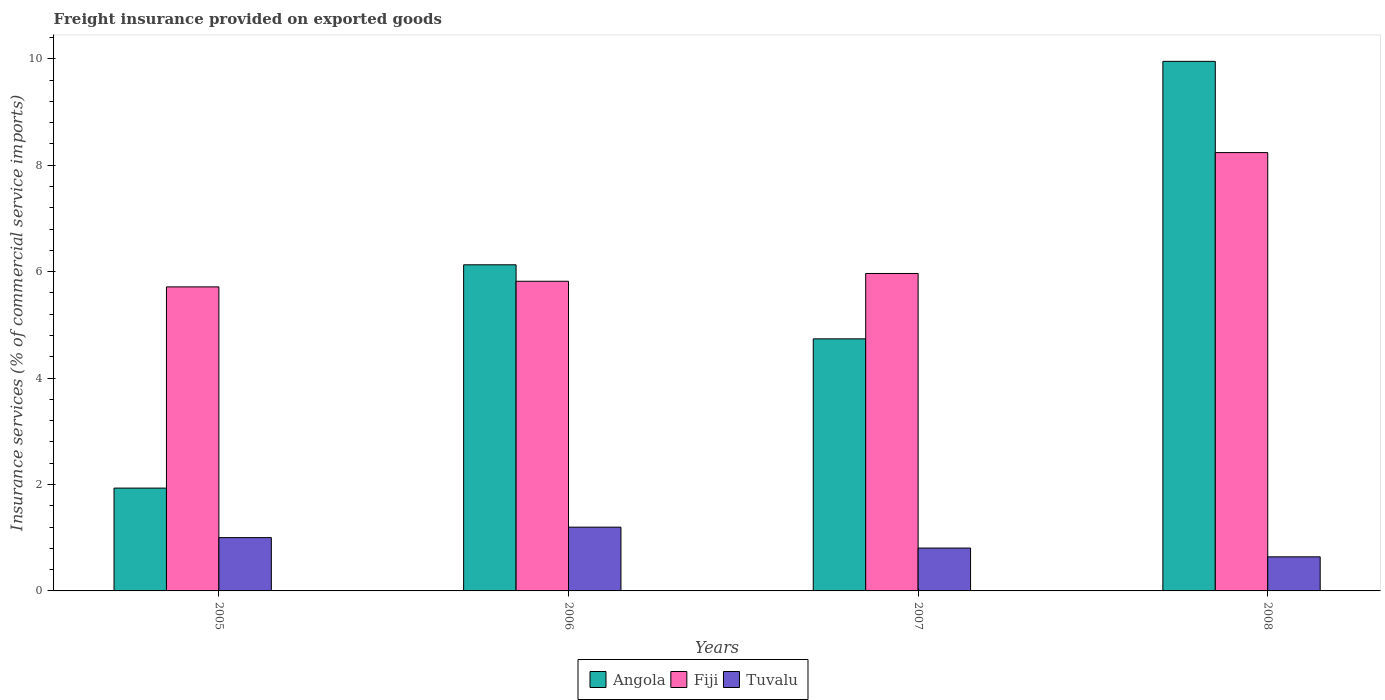How many different coloured bars are there?
Offer a terse response. 3. Are the number of bars per tick equal to the number of legend labels?
Give a very brief answer. Yes. How many bars are there on the 4th tick from the left?
Your answer should be very brief. 3. What is the label of the 3rd group of bars from the left?
Keep it short and to the point. 2007. What is the freight insurance provided on exported goods in Angola in 2005?
Your response must be concise. 1.93. Across all years, what is the maximum freight insurance provided on exported goods in Angola?
Your response must be concise. 9.95. Across all years, what is the minimum freight insurance provided on exported goods in Fiji?
Ensure brevity in your answer.  5.71. In which year was the freight insurance provided on exported goods in Tuvalu minimum?
Offer a very short reply. 2008. What is the total freight insurance provided on exported goods in Fiji in the graph?
Offer a terse response. 25.73. What is the difference between the freight insurance provided on exported goods in Fiji in 2006 and that in 2007?
Give a very brief answer. -0.15. What is the difference between the freight insurance provided on exported goods in Angola in 2007 and the freight insurance provided on exported goods in Tuvalu in 2008?
Ensure brevity in your answer.  4.1. What is the average freight insurance provided on exported goods in Fiji per year?
Provide a succinct answer. 6.43. In the year 2007, what is the difference between the freight insurance provided on exported goods in Angola and freight insurance provided on exported goods in Tuvalu?
Ensure brevity in your answer.  3.93. What is the ratio of the freight insurance provided on exported goods in Angola in 2005 to that in 2007?
Provide a succinct answer. 0.41. Is the freight insurance provided on exported goods in Angola in 2006 less than that in 2008?
Provide a succinct answer. Yes. What is the difference between the highest and the second highest freight insurance provided on exported goods in Angola?
Give a very brief answer. 3.82. What is the difference between the highest and the lowest freight insurance provided on exported goods in Fiji?
Your answer should be very brief. 2.52. In how many years, is the freight insurance provided on exported goods in Fiji greater than the average freight insurance provided on exported goods in Fiji taken over all years?
Your answer should be very brief. 1. What does the 1st bar from the left in 2005 represents?
Offer a very short reply. Angola. What does the 1st bar from the right in 2007 represents?
Offer a very short reply. Tuvalu. Is it the case that in every year, the sum of the freight insurance provided on exported goods in Fiji and freight insurance provided on exported goods in Angola is greater than the freight insurance provided on exported goods in Tuvalu?
Your answer should be compact. Yes. Are the values on the major ticks of Y-axis written in scientific E-notation?
Your response must be concise. No. Does the graph contain any zero values?
Provide a short and direct response. No. Does the graph contain grids?
Provide a succinct answer. No. Where does the legend appear in the graph?
Offer a very short reply. Bottom center. How many legend labels are there?
Provide a succinct answer. 3. What is the title of the graph?
Offer a very short reply. Freight insurance provided on exported goods. What is the label or title of the X-axis?
Make the answer very short. Years. What is the label or title of the Y-axis?
Ensure brevity in your answer.  Insurance services (% of commercial service imports). What is the Insurance services (% of commercial service imports) in Angola in 2005?
Offer a terse response. 1.93. What is the Insurance services (% of commercial service imports) in Fiji in 2005?
Your response must be concise. 5.71. What is the Insurance services (% of commercial service imports) in Tuvalu in 2005?
Your answer should be very brief. 1. What is the Insurance services (% of commercial service imports) in Angola in 2006?
Your answer should be very brief. 6.13. What is the Insurance services (% of commercial service imports) of Fiji in 2006?
Give a very brief answer. 5.82. What is the Insurance services (% of commercial service imports) in Tuvalu in 2006?
Ensure brevity in your answer.  1.2. What is the Insurance services (% of commercial service imports) in Angola in 2007?
Make the answer very short. 4.74. What is the Insurance services (% of commercial service imports) in Fiji in 2007?
Ensure brevity in your answer.  5.97. What is the Insurance services (% of commercial service imports) of Tuvalu in 2007?
Your response must be concise. 0.81. What is the Insurance services (% of commercial service imports) in Angola in 2008?
Make the answer very short. 9.95. What is the Insurance services (% of commercial service imports) in Fiji in 2008?
Your answer should be very brief. 8.24. What is the Insurance services (% of commercial service imports) in Tuvalu in 2008?
Give a very brief answer. 0.64. Across all years, what is the maximum Insurance services (% of commercial service imports) in Angola?
Your answer should be compact. 9.95. Across all years, what is the maximum Insurance services (% of commercial service imports) in Fiji?
Ensure brevity in your answer.  8.24. Across all years, what is the maximum Insurance services (% of commercial service imports) of Tuvalu?
Provide a short and direct response. 1.2. Across all years, what is the minimum Insurance services (% of commercial service imports) of Angola?
Keep it short and to the point. 1.93. Across all years, what is the minimum Insurance services (% of commercial service imports) in Fiji?
Offer a terse response. 5.71. Across all years, what is the minimum Insurance services (% of commercial service imports) in Tuvalu?
Make the answer very short. 0.64. What is the total Insurance services (% of commercial service imports) in Angola in the graph?
Offer a very short reply. 22.75. What is the total Insurance services (% of commercial service imports) in Fiji in the graph?
Provide a succinct answer. 25.73. What is the total Insurance services (% of commercial service imports) in Tuvalu in the graph?
Your response must be concise. 3.65. What is the difference between the Insurance services (% of commercial service imports) in Angola in 2005 and that in 2006?
Provide a short and direct response. -4.2. What is the difference between the Insurance services (% of commercial service imports) of Fiji in 2005 and that in 2006?
Offer a terse response. -0.11. What is the difference between the Insurance services (% of commercial service imports) of Tuvalu in 2005 and that in 2006?
Offer a terse response. -0.2. What is the difference between the Insurance services (% of commercial service imports) of Angola in 2005 and that in 2007?
Provide a succinct answer. -2.8. What is the difference between the Insurance services (% of commercial service imports) of Fiji in 2005 and that in 2007?
Provide a short and direct response. -0.25. What is the difference between the Insurance services (% of commercial service imports) of Tuvalu in 2005 and that in 2007?
Your answer should be compact. 0.2. What is the difference between the Insurance services (% of commercial service imports) in Angola in 2005 and that in 2008?
Offer a very short reply. -8.02. What is the difference between the Insurance services (% of commercial service imports) of Fiji in 2005 and that in 2008?
Keep it short and to the point. -2.52. What is the difference between the Insurance services (% of commercial service imports) of Tuvalu in 2005 and that in 2008?
Provide a short and direct response. 0.36. What is the difference between the Insurance services (% of commercial service imports) of Angola in 2006 and that in 2007?
Provide a succinct answer. 1.39. What is the difference between the Insurance services (% of commercial service imports) of Fiji in 2006 and that in 2007?
Offer a terse response. -0.15. What is the difference between the Insurance services (% of commercial service imports) of Tuvalu in 2006 and that in 2007?
Ensure brevity in your answer.  0.39. What is the difference between the Insurance services (% of commercial service imports) of Angola in 2006 and that in 2008?
Provide a short and direct response. -3.82. What is the difference between the Insurance services (% of commercial service imports) of Fiji in 2006 and that in 2008?
Your response must be concise. -2.42. What is the difference between the Insurance services (% of commercial service imports) of Tuvalu in 2006 and that in 2008?
Provide a succinct answer. 0.56. What is the difference between the Insurance services (% of commercial service imports) in Angola in 2007 and that in 2008?
Provide a short and direct response. -5.21. What is the difference between the Insurance services (% of commercial service imports) of Fiji in 2007 and that in 2008?
Ensure brevity in your answer.  -2.27. What is the difference between the Insurance services (% of commercial service imports) of Tuvalu in 2007 and that in 2008?
Offer a very short reply. 0.16. What is the difference between the Insurance services (% of commercial service imports) of Angola in 2005 and the Insurance services (% of commercial service imports) of Fiji in 2006?
Provide a succinct answer. -3.89. What is the difference between the Insurance services (% of commercial service imports) in Angola in 2005 and the Insurance services (% of commercial service imports) in Tuvalu in 2006?
Provide a succinct answer. 0.73. What is the difference between the Insurance services (% of commercial service imports) in Fiji in 2005 and the Insurance services (% of commercial service imports) in Tuvalu in 2006?
Make the answer very short. 4.52. What is the difference between the Insurance services (% of commercial service imports) of Angola in 2005 and the Insurance services (% of commercial service imports) of Fiji in 2007?
Ensure brevity in your answer.  -4.03. What is the difference between the Insurance services (% of commercial service imports) of Angola in 2005 and the Insurance services (% of commercial service imports) of Tuvalu in 2007?
Offer a very short reply. 1.13. What is the difference between the Insurance services (% of commercial service imports) in Fiji in 2005 and the Insurance services (% of commercial service imports) in Tuvalu in 2007?
Ensure brevity in your answer.  4.91. What is the difference between the Insurance services (% of commercial service imports) of Angola in 2005 and the Insurance services (% of commercial service imports) of Fiji in 2008?
Your response must be concise. -6.3. What is the difference between the Insurance services (% of commercial service imports) of Angola in 2005 and the Insurance services (% of commercial service imports) of Tuvalu in 2008?
Keep it short and to the point. 1.29. What is the difference between the Insurance services (% of commercial service imports) of Fiji in 2005 and the Insurance services (% of commercial service imports) of Tuvalu in 2008?
Offer a very short reply. 5.07. What is the difference between the Insurance services (% of commercial service imports) of Angola in 2006 and the Insurance services (% of commercial service imports) of Fiji in 2007?
Provide a succinct answer. 0.16. What is the difference between the Insurance services (% of commercial service imports) of Angola in 2006 and the Insurance services (% of commercial service imports) of Tuvalu in 2007?
Your answer should be very brief. 5.32. What is the difference between the Insurance services (% of commercial service imports) of Fiji in 2006 and the Insurance services (% of commercial service imports) of Tuvalu in 2007?
Your answer should be very brief. 5.01. What is the difference between the Insurance services (% of commercial service imports) in Angola in 2006 and the Insurance services (% of commercial service imports) in Fiji in 2008?
Offer a very short reply. -2.11. What is the difference between the Insurance services (% of commercial service imports) of Angola in 2006 and the Insurance services (% of commercial service imports) of Tuvalu in 2008?
Offer a terse response. 5.49. What is the difference between the Insurance services (% of commercial service imports) in Fiji in 2006 and the Insurance services (% of commercial service imports) in Tuvalu in 2008?
Provide a succinct answer. 5.18. What is the difference between the Insurance services (% of commercial service imports) in Angola in 2007 and the Insurance services (% of commercial service imports) in Fiji in 2008?
Your answer should be very brief. -3.5. What is the difference between the Insurance services (% of commercial service imports) of Angola in 2007 and the Insurance services (% of commercial service imports) of Tuvalu in 2008?
Provide a succinct answer. 4.1. What is the difference between the Insurance services (% of commercial service imports) in Fiji in 2007 and the Insurance services (% of commercial service imports) in Tuvalu in 2008?
Ensure brevity in your answer.  5.32. What is the average Insurance services (% of commercial service imports) in Angola per year?
Your answer should be compact. 5.69. What is the average Insurance services (% of commercial service imports) in Fiji per year?
Ensure brevity in your answer.  6.43. What is the average Insurance services (% of commercial service imports) of Tuvalu per year?
Offer a very short reply. 0.91. In the year 2005, what is the difference between the Insurance services (% of commercial service imports) of Angola and Insurance services (% of commercial service imports) of Fiji?
Provide a succinct answer. -3.78. In the year 2005, what is the difference between the Insurance services (% of commercial service imports) in Angola and Insurance services (% of commercial service imports) in Tuvalu?
Keep it short and to the point. 0.93. In the year 2005, what is the difference between the Insurance services (% of commercial service imports) of Fiji and Insurance services (% of commercial service imports) of Tuvalu?
Offer a very short reply. 4.71. In the year 2006, what is the difference between the Insurance services (% of commercial service imports) in Angola and Insurance services (% of commercial service imports) in Fiji?
Your response must be concise. 0.31. In the year 2006, what is the difference between the Insurance services (% of commercial service imports) in Angola and Insurance services (% of commercial service imports) in Tuvalu?
Offer a terse response. 4.93. In the year 2006, what is the difference between the Insurance services (% of commercial service imports) of Fiji and Insurance services (% of commercial service imports) of Tuvalu?
Make the answer very short. 4.62. In the year 2007, what is the difference between the Insurance services (% of commercial service imports) of Angola and Insurance services (% of commercial service imports) of Fiji?
Your response must be concise. -1.23. In the year 2007, what is the difference between the Insurance services (% of commercial service imports) in Angola and Insurance services (% of commercial service imports) in Tuvalu?
Your answer should be very brief. 3.93. In the year 2007, what is the difference between the Insurance services (% of commercial service imports) of Fiji and Insurance services (% of commercial service imports) of Tuvalu?
Keep it short and to the point. 5.16. In the year 2008, what is the difference between the Insurance services (% of commercial service imports) of Angola and Insurance services (% of commercial service imports) of Fiji?
Offer a very short reply. 1.71. In the year 2008, what is the difference between the Insurance services (% of commercial service imports) of Angola and Insurance services (% of commercial service imports) of Tuvalu?
Your response must be concise. 9.31. In the year 2008, what is the difference between the Insurance services (% of commercial service imports) in Fiji and Insurance services (% of commercial service imports) in Tuvalu?
Provide a short and direct response. 7.6. What is the ratio of the Insurance services (% of commercial service imports) in Angola in 2005 to that in 2006?
Your answer should be very brief. 0.32. What is the ratio of the Insurance services (% of commercial service imports) in Fiji in 2005 to that in 2006?
Make the answer very short. 0.98. What is the ratio of the Insurance services (% of commercial service imports) of Tuvalu in 2005 to that in 2006?
Your answer should be very brief. 0.84. What is the ratio of the Insurance services (% of commercial service imports) of Angola in 2005 to that in 2007?
Provide a short and direct response. 0.41. What is the ratio of the Insurance services (% of commercial service imports) of Fiji in 2005 to that in 2007?
Offer a very short reply. 0.96. What is the ratio of the Insurance services (% of commercial service imports) in Tuvalu in 2005 to that in 2007?
Ensure brevity in your answer.  1.24. What is the ratio of the Insurance services (% of commercial service imports) in Angola in 2005 to that in 2008?
Your answer should be very brief. 0.19. What is the ratio of the Insurance services (% of commercial service imports) in Fiji in 2005 to that in 2008?
Ensure brevity in your answer.  0.69. What is the ratio of the Insurance services (% of commercial service imports) in Tuvalu in 2005 to that in 2008?
Your response must be concise. 1.56. What is the ratio of the Insurance services (% of commercial service imports) of Angola in 2006 to that in 2007?
Ensure brevity in your answer.  1.29. What is the ratio of the Insurance services (% of commercial service imports) in Fiji in 2006 to that in 2007?
Give a very brief answer. 0.98. What is the ratio of the Insurance services (% of commercial service imports) in Tuvalu in 2006 to that in 2007?
Make the answer very short. 1.49. What is the ratio of the Insurance services (% of commercial service imports) in Angola in 2006 to that in 2008?
Make the answer very short. 0.62. What is the ratio of the Insurance services (% of commercial service imports) of Fiji in 2006 to that in 2008?
Give a very brief answer. 0.71. What is the ratio of the Insurance services (% of commercial service imports) of Tuvalu in 2006 to that in 2008?
Your response must be concise. 1.87. What is the ratio of the Insurance services (% of commercial service imports) in Angola in 2007 to that in 2008?
Your response must be concise. 0.48. What is the ratio of the Insurance services (% of commercial service imports) of Fiji in 2007 to that in 2008?
Your response must be concise. 0.72. What is the ratio of the Insurance services (% of commercial service imports) of Tuvalu in 2007 to that in 2008?
Keep it short and to the point. 1.26. What is the difference between the highest and the second highest Insurance services (% of commercial service imports) in Angola?
Provide a succinct answer. 3.82. What is the difference between the highest and the second highest Insurance services (% of commercial service imports) of Fiji?
Keep it short and to the point. 2.27. What is the difference between the highest and the second highest Insurance services (% of commercial service imports) in Tuvalu?
Your answer should be very brief. 0.2. What is the difference between the highest and the lowest Insurance services (% of commercial service imports) in Angola?
Make the answer very short. 8.02. What is the difference between the highest and the lowest Insurance services (% of commercial service imports) of Fiji?
Offer a terse response. 2.52. What is the difference between the highest and the lowest Insurance services (% of commercial service imports) in Tuvalu?
Your response must be concise. 0.56. 